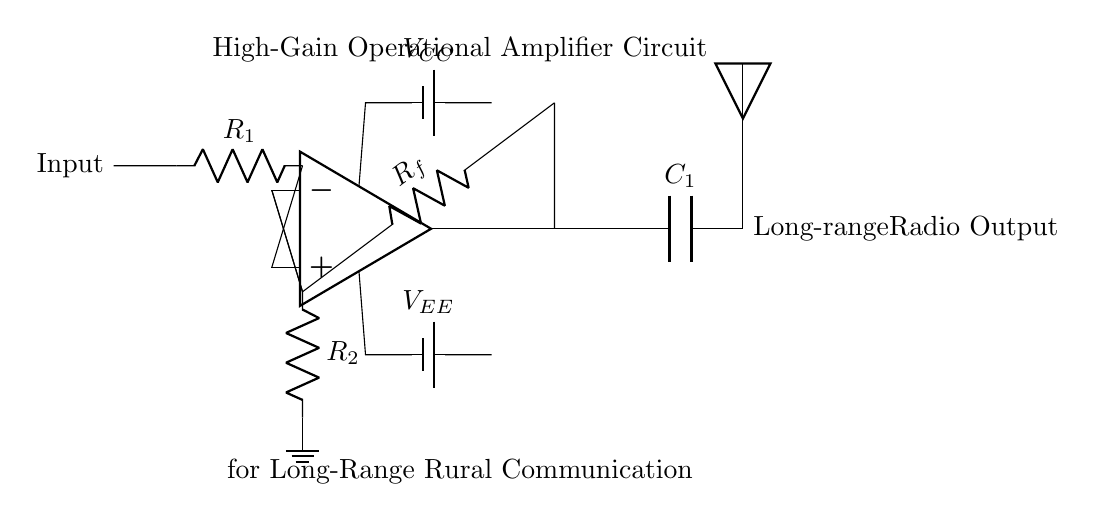What is the type of operational amplifier used in this circuit? The circuit diagram indicates an ideal operational amplifier symbol, suggesting it is a high-gain op-amp designed for amplification.
Answer: ideal operational amplifier What component is used for feedback in this circuit? The feedback in the circuit is provided by the resistor labeled R sub f, connecting from the output back to the inverting input.
Answer: R sub f What is the purpose of the capacitor C1? The capacitor C sub 1 is connected to the output and serves as a coupling capacitor, allowing AC signals to pass while blocking DC components to the antenna.
Answer: coupling capacitor What is the role of resistor R1? Resistor R sub 1 is the input resistor that determines the gain of the amplifier by forming a voltage divider with resistor R sub f and setting the input signal level.
Answer: input resistor How do the power supply voltages influence the op-amp? The op-amp is powered by V sub CC and V sub EE, providing the necessary voltage levels for amplification; V sub CC powers the positive side, and V sub EE powers the negative side.
Answer: power supply voltages What is the result of increasing the value of R sub f? Increasing the value of R sub f will increase the gain of the operational amplifier circuit, amplifying the signal more before it reaches the antenna.
Answer: increase in gain 